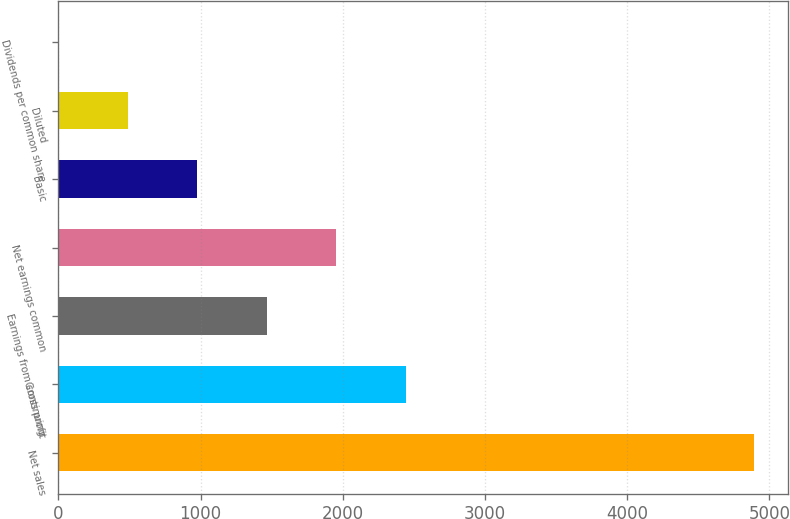Convert chart. <chart><loc_0><loc_0><loc_500><loc_500><bar_chart><fcel>Net sales<fcel>Gross profit<fcel>Earnings from continuing<fcel>Net earnings common<fcel>Basic<fcel>Diluted<fcel>Dividends per common share<nl><fcel>4888<fcel>2444.23<fcel>1466.73<fcel>1955.48<fcel>977.98<fcel>489.23<fcel>0.48<nl></chart> 